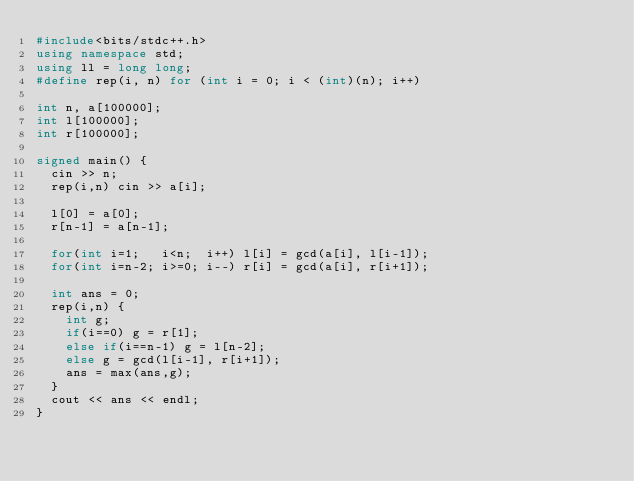<code> <loc_0><loc_0><loc_500><loc_500><_C++_>#include<bits/stdc++.h>
using namespace std;
using ll = long long;
#define rep(i, n) for (int i = 0; i < (int)(n); i++)

int n, a[100000];
int l[100000];
int r[100000];

signed main() {
  cin >> n;
  rep(i,n) cin >> a[i];

  l[0] = a[0];
  r[n-1] = a[n-1];

  for(int i=1;   i<n;  i++) l[i] = gcd(a[i], l[i-1]);
  for(int i=n-2; i>=0; i--) r[i] = gcd(a[i], r[i+1]);

  int ans = 0;
  rep(i,n) {
    int g;
    if(i==0) g = r[1];
    else if(i==n-1) g = l[n-2];
    else g = gcd(l[i-1], r[i+1]); 
    ans = max(ans,g);
  }
  cout << ans << endl;
}
</code> 